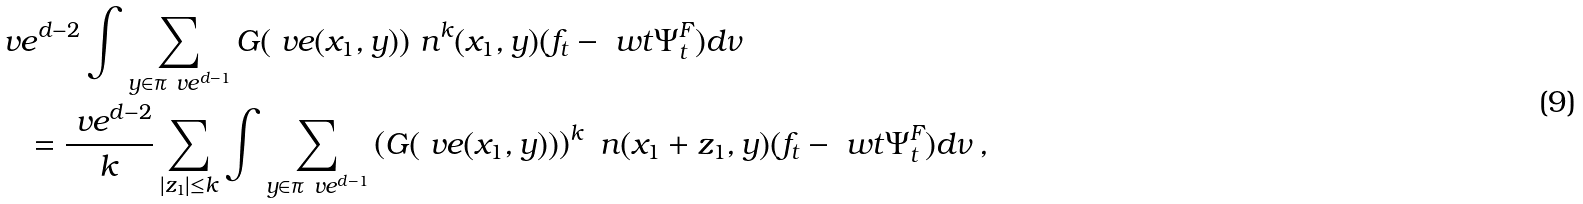<formula> <loc_0><loc_0><loc_500><loc_500>& \ v e ^ { d - 2 } \int \sum _ { y \in \pi _ { \ } v e ^ { d - 1 } } G ( \ v e ( x _ { 1 } , y ) ) \ n ^ { k } ( x _ { 1 } , y ) ( f _ { t } - \ w t { \Psi } _ { t } ^ { F } ) d \nu \\ & \quad = \frac { \ v e ^ { d - 2 } } { k } \sum _ { | z _ { 1 } | \leq k } \int \sum _ { y \in \pi _ { \ } v e ^ { d - 1 } } \left ( G ( \ v e ( x _ { 1 } , y ) ) \right ) ^ { k } \ n ( x _ { 1 } + z _ { 1 } , y ) ( f _ { t } - \ w t { \Psi } _ { t } ^ { F } ) d \nu \, ,</formula> 